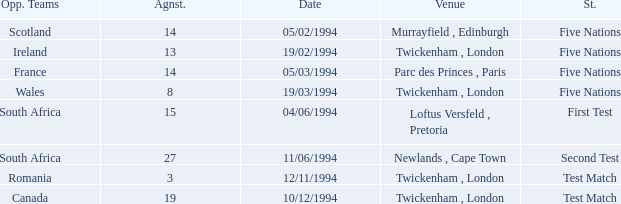Which venue has more than 19 against? Newlands , Cape Town. 